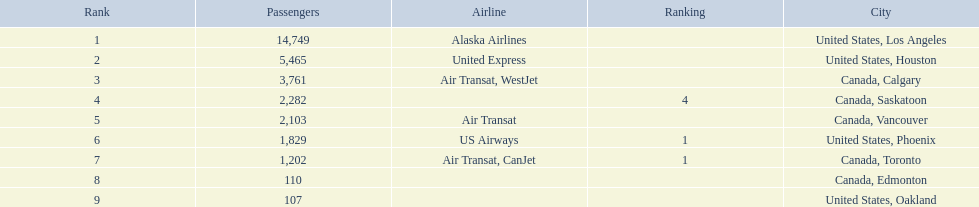What cities do the planes fly to? United States, Los Angeles, United States, Houston, Canada, Calgary, Canada, Saskatoon, Canada, Vancouver, United States, Phoenix, Canada, Toronto, Canada, Edmonton, United States, Oakland. How many people are flying to phoenix, arizona? 1,829. 